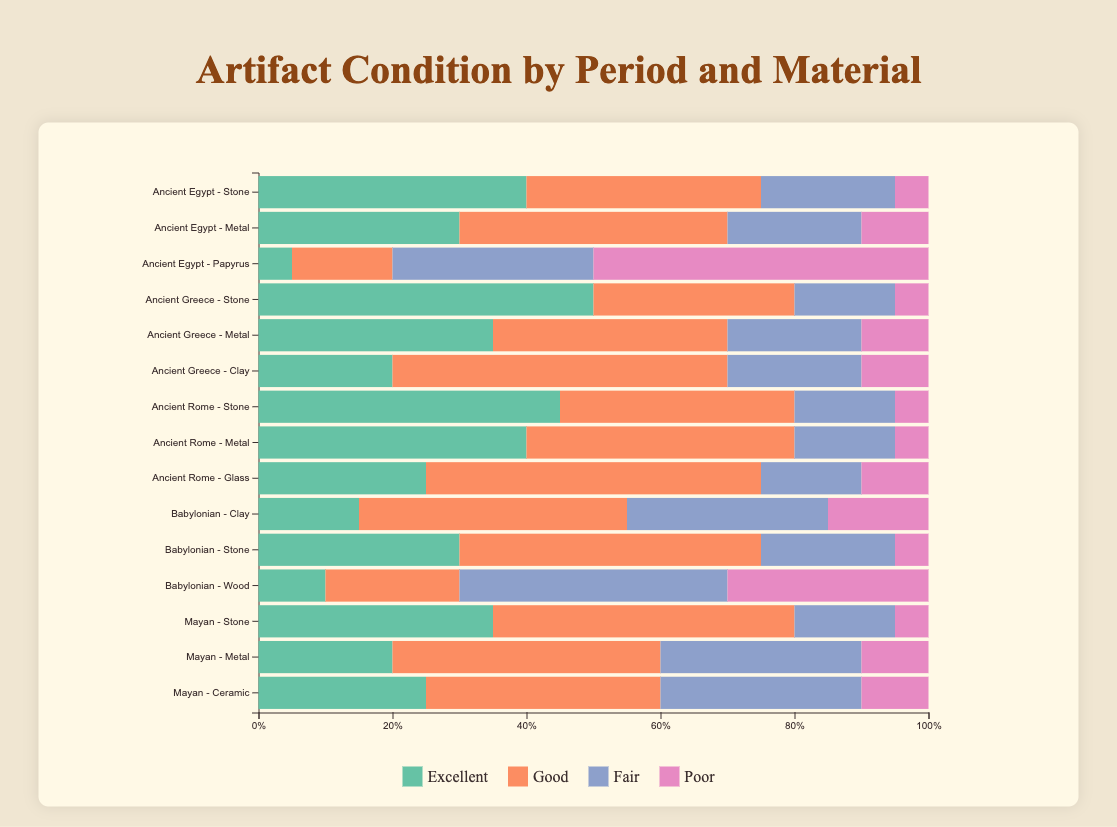Which civilization has the highest percentage of artifacts in excellent condition in the Stone category? To find the answer, locate each Stone row and compare the percentage in excellent condition. Ancient Greece has 50%, Ancient Rome 45%, Babylonian 30%, Ancient Egypt 40%, and Mayan 35%.
Answer: Ancient Greece Which material from the Ancient Egypt period has the highest percentage of artifacts in poor condition? Compare the "Poor" percentage for each material in the Ancient Egypt period. Stone has 5%, Metal 10%, and Papyrus 50%.
Answer: Papyrus Which period has the most balanced distribution of artifact conditions for metal? Compare the percentages of each condition category for metal across each period. Balancing implies relatively equal distribution among the categories. For Ancient Egypt: 30% (Excellent), 40% (Good), 20% (Fair), 10% (Poor). Ancient Greece: 35% (Excellent), 35% (Good), 20% (Fair), 10% (Poor). Ancient Rome: 40% (Excellent), 40% (Good), 15% (Fair), 5% (Poor).
Answer: Ancient Greece Which civilization has the highest total percentage of artifacts in good condition? For each civilization, sum the "Good" percentages across all materials. Ancient Egypt: 35 + 40 + 15 = 90%. Ancient Greece: 30 + 35 + 50 = 115%. Ancient Rome: 35 + 40 + 50 = 125%. Babylonian: 40 + 45 + 20 = 105%. Mayan: 45 + 40 + 35 = 120%.
Answer: Ancient Rome What is the difference in percentage of artifacts in excellent condition between Mayan Stone and Babylonian Stone? Find the "Excellent" percentages for Mayan Stone (35%) and Babylonian Stone (30%), then compute the difference: 35% - 30% = 5%.
Answer: 5% Which material from the Ancient Rome period has the lowest percentage of artifacts in fair condition? Compare the "Fair" percentages for each material in the Ancient Rome period. Stone has 15%, Metal 15%, and Glass 15%. Therefore, all are equal, indicating no single lowest.
Answer: All equal Which has a higher percentage of artifacts in excellent condition, Babylonian Clay or Babylonian Stone? Compare the "Excellent" percentages for Babylonian Clay (15%) and Babylonian Stone (30%).
Answer: Babylonian Stone Among the civilizations displayed, which has the highest percentage of artifacts in poor condition for any single material? Check the "Poor" percentages for each material within each period, and find the maximum value. Ancient Egypt Papyrus has 50%.
Answer: Ancient Egypt Papyrus How does the percentage of artifacts in fair condition for Mayan Metal compare to the percentage in fair condition for Mayan Ceramic? Compare the "Fair" percentages for Mayan Metal (30%) and Mayan Ceramic (30%).
Answer: Equal 